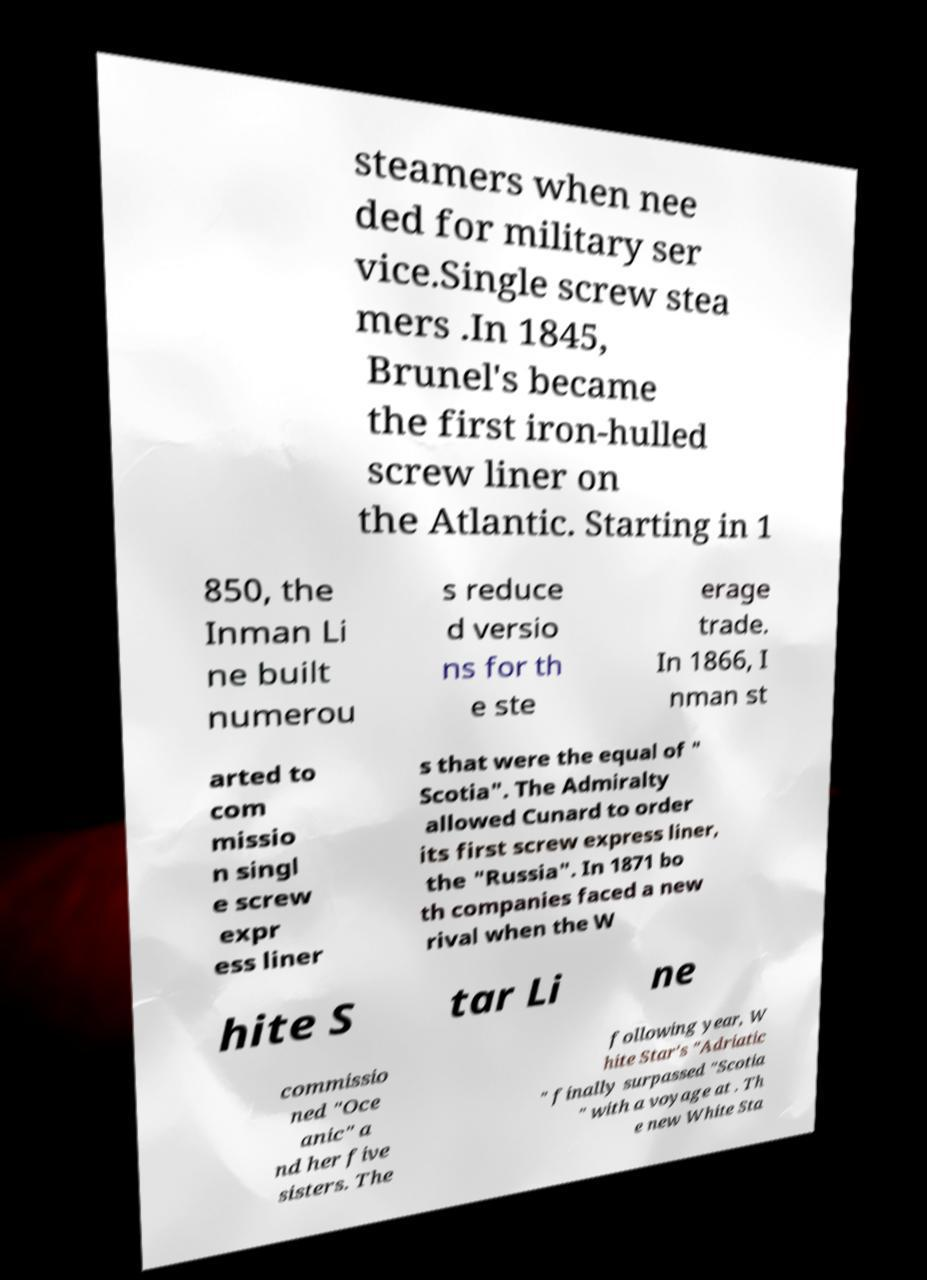For documentation purposes, I need the text within this image transcribed. Could you provide that? steamers when nee ded for military ser vice.Single screw stea mers .In 1845, Brunel's became the first iron-hulled screw liner on the Atlantic. Starting in 1 850, the Inman Li ne built numerou s reduce d versio ns for th e ste erage trade. In 1866, I nman st arted to com missio n singl e screw expr ess liner s that were the equal of " Scotia". The Admiralty allowed Cunard to order its first screw express liner, the "Russia". In 1871 bo th companies faced a new rival when the W hite S tar Li ne commissio ned "Oce anic" a nd her five sisters. The following year, W hite Star's "Adriatic " finally surpassed "Scotia " with a voyage at . Th e new White Sta 